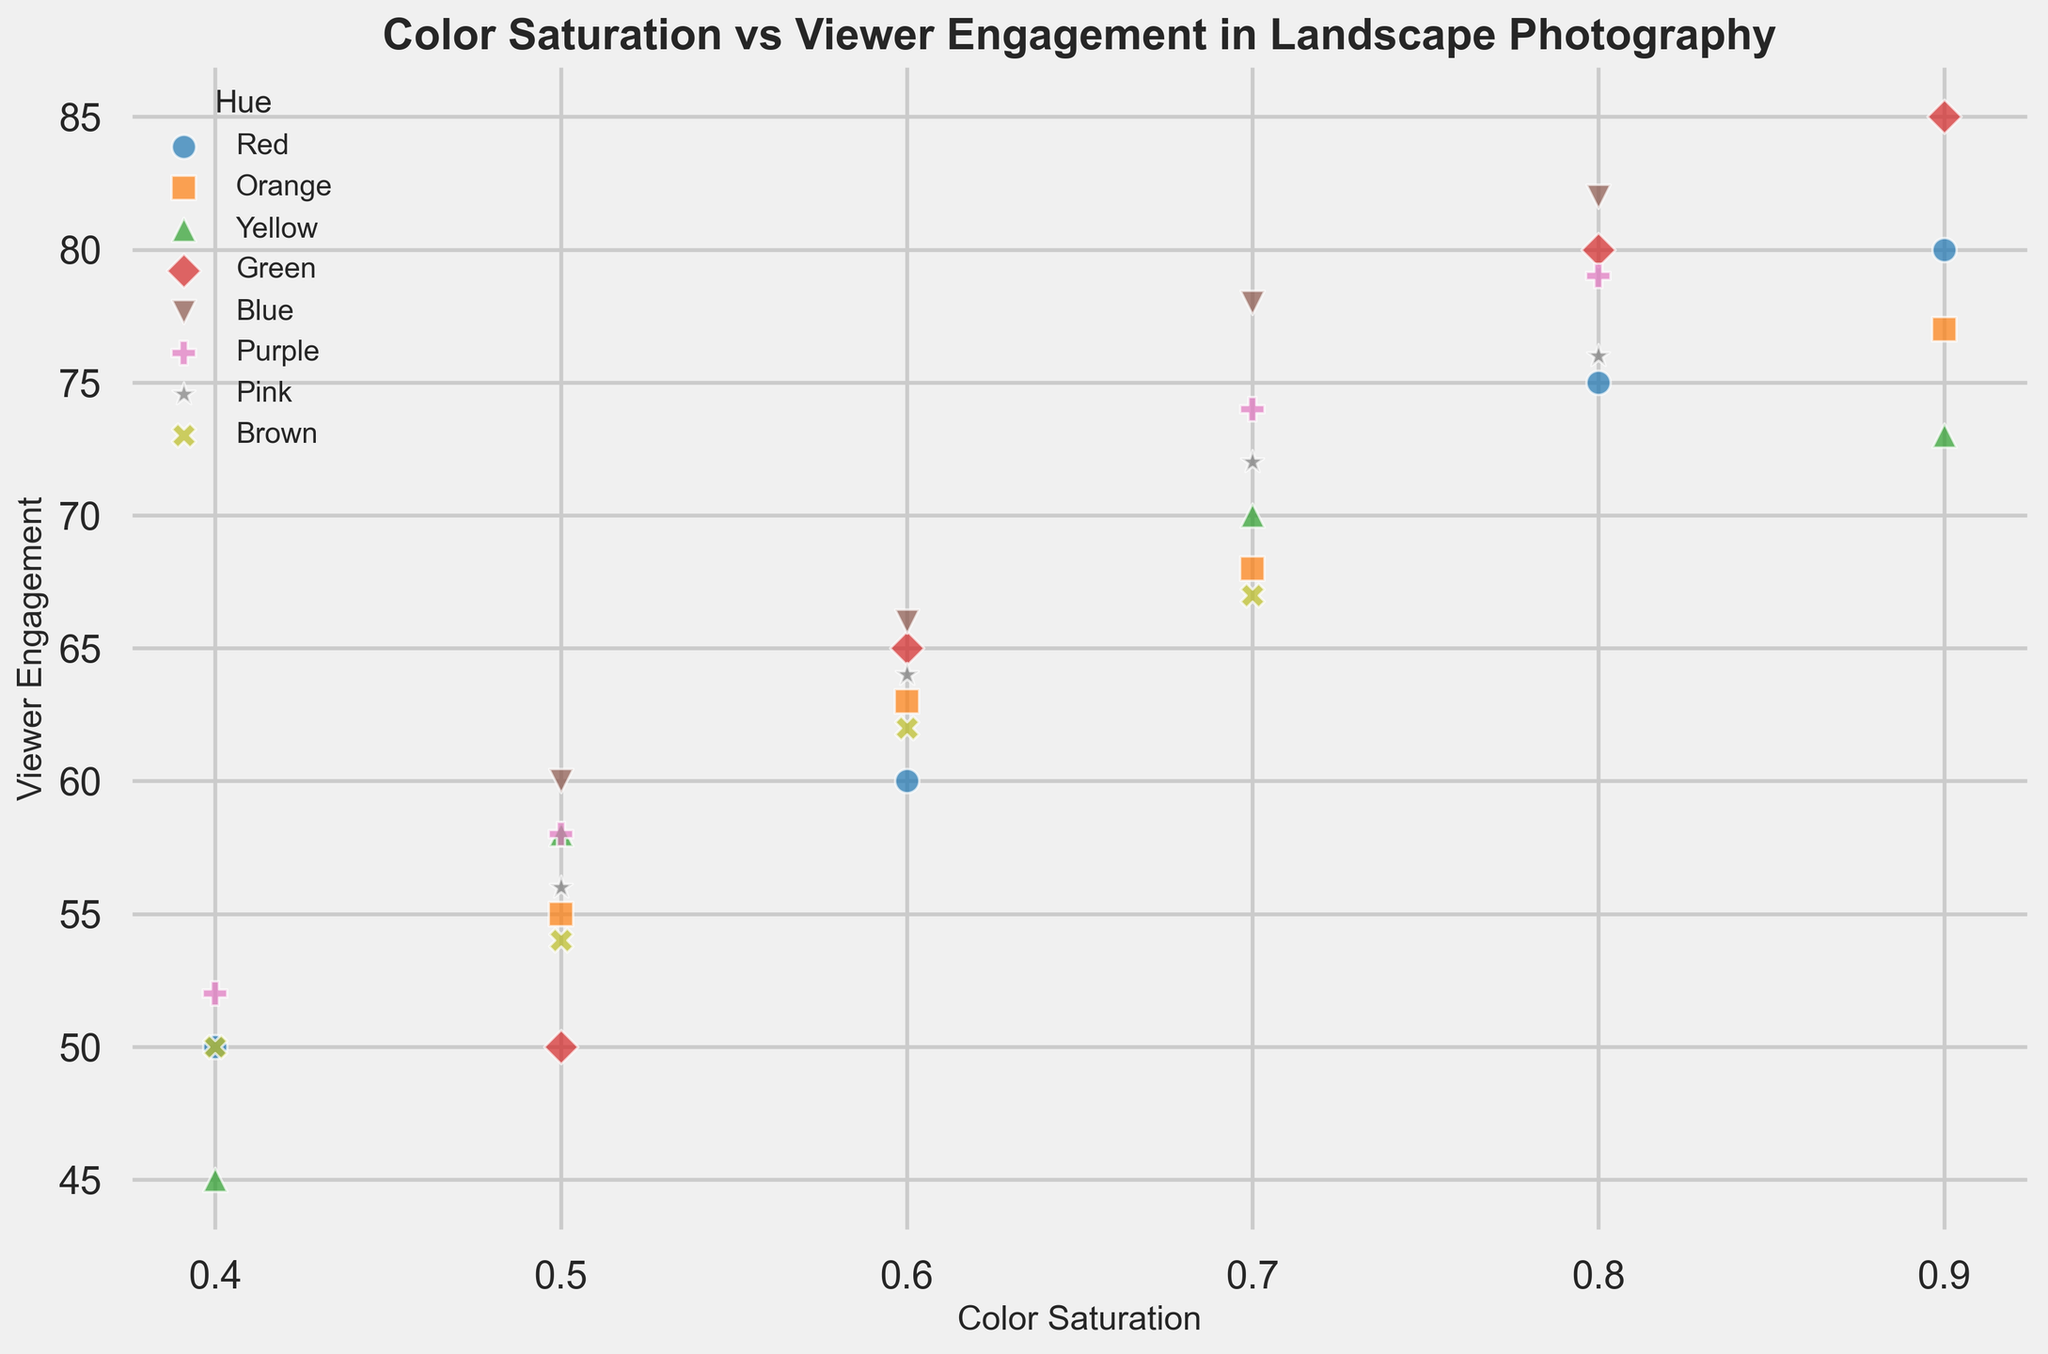What's the color hue with the highest viewer engagement for a saturation level of 0.9? The plot shows different hues at various saturation levels. Identify the points with a color saturation of 0.9 and compare their viewer engagement scores. Green has the highest value at 85.
Answer: Green Which hue shows the lowest viewer engagement at a saturation level of 0.4? Identify the points on the scatter plot with a saturation level of 0.4 and compare their viewer engagement scores. Black_White has the lowest value at 47.
Answer: Black_White Compare the average viewer engagement for Red and Blue hues. Which one has higher average engagement? Calculate the mean viewer engagement for Red by summing the Red points: (75 + 60 + 80 + 50) / 4 = 66.25. Similarly, for Blue: (78 + 60 + 82 + 66) / 4 = 71.5. Blue has higher average engagement.
Answer: Blue Does a higher color saturation always lead to higher viewer engagement for Green? Check if viewer engagement increases consistently with increasing saturation levels for Green. Engagments for Green are 50 (0.5), 65 (0.6), 80 (0.8), 85 (0.9). As saturation increases, engagement also increases.
Answer: Yes Which hue has the most consistent viewer engagement across different saturation levels, and how do you determine this? Consistency can be interpreted by checking how close engagement values are across different saturation levels. Check the range of viewer engagement for each hue. For example, Pink has relatively consistent viewer engagements: 72, 56, 76, 64, with less variation compared to other hues.
Answer: Pink What is the viewer engagement difference between the highest and lowest engaging colors for 0.7 saturation level? Identify the hues at 0.7 saturation and find their engagement scores: Red (68), Orange (70), Yellow (67), Green (78), Blue (70), Purple (74), Pink (72), Brown (67). Max engagement is 78 (Green), Min is 67 (Yellow/Brown). Difference = 78 - 67 = 11.
Answer: 11 Do black and white photographs show a linear relationship between color saturation and viewer engagement? Check the viewer engagement for Black_White at different saturation levels: 40 (0.1), 42 (0.2), 45 (0.3), 47 (0.4). Engagement increases steadily as saturation increases, suggesting a linear relationship.
Answer: Yes Is there any color with a saturation of 0.5 that has viewer engagement above 60? Check all the points with saturation of 0.5 and their engagement scores. None of the colors (Orange, Yellow, Green, Blue, Purple, Pink, Brown) have engagement above 60.
Answer: No How does the average viewer engagement for hues with saturation levels of 0.6 compare to those with 0.7? Compute the averages. Hues at 0.6: Red (60), Orange (63), Green (65), Blue (66), Pink (64), Brown (62) Average = 63.33. Hues at 0.7: Red (75), Orange (68), Yellow (70), Green (78), Blue (78), Purple (74), Pink (72), Brown (67) Average = 72.75. Higher for 0.7 saturation.
Answer: 0.7 saturation Which hue has the largest variance in viewer engagement across all saturation levels? Calculate variance for each hue. Red: 116.67, Orange: 88, Yellow: 128.33, Green: 227.5, Blue: 116.67, Purple: 107.67, Pink: 88.67, Brown: 34.33, Black_White: 9.5. Green has the highest variance.
Answer: Green 